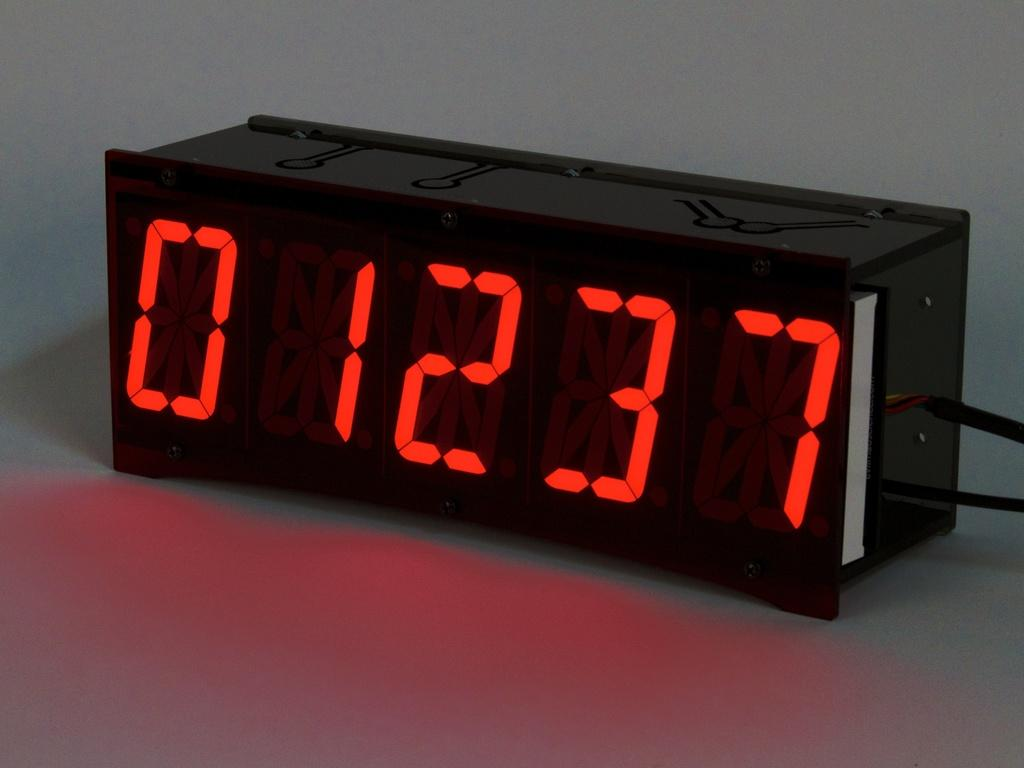<image>
Relay a brief, clear account of the picture shown. Numbers 01237 are shown in neon red on a black background. 